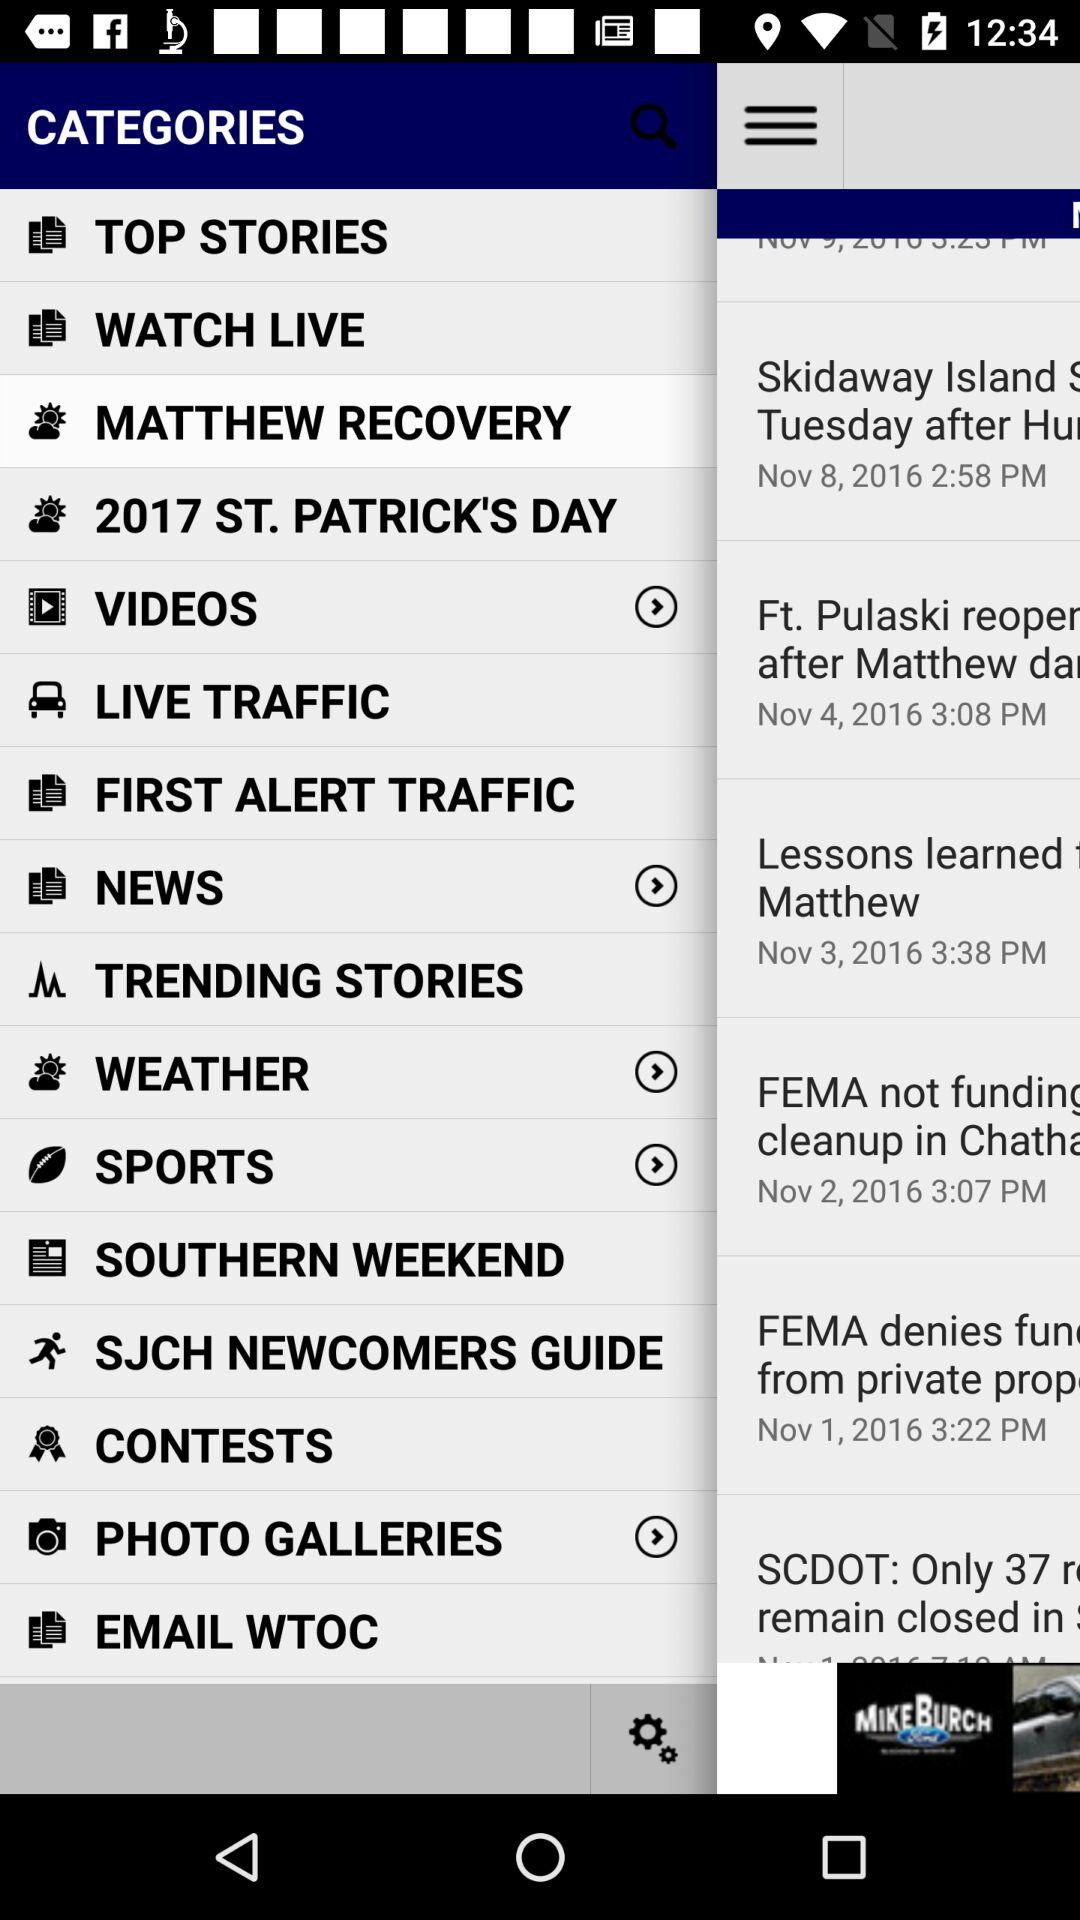Which category is selected? The selected category is "MATTHEW RECOVERY". 